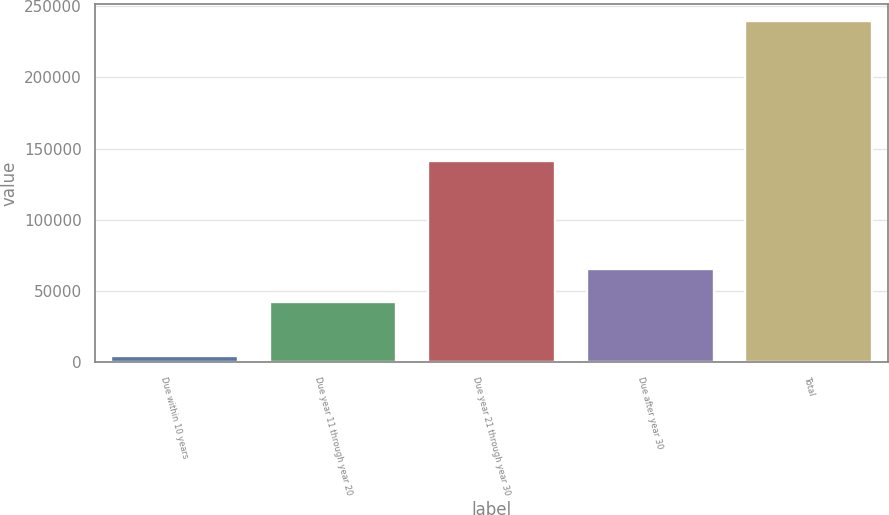<chart> <loc_0><loc_0><loc_500><loc_500><bar_chart><fcel>Due within 10 years<fcel>Due year 11 through year 20<fcel>Due year 21 through year 30<fcel>Due after year 30<fcel>Total<nl><fcel>4000<fcel>42100<fcel>141450<fcel>65670<fcel>239700<nl></chart> 